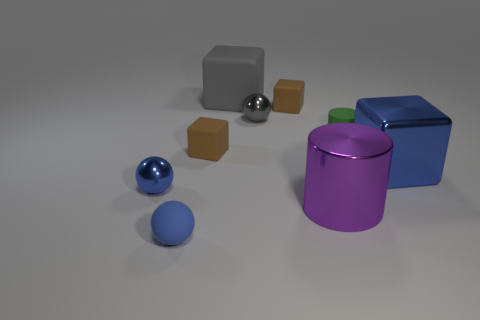What number of things are either small blocks to the left of the big gray matte cube or large cubes?
Ensure brevity in your answer.  3. The tiny shiny object to the right of the big block to the left of the big shiny thing right of the purple metallic cylinder is what shape?
Ensure brevity in your answer.  Sphere. What number of blue things have the same shape as the large purple object?
Offer a terse response. 0. There is a sphere that is the same color as the large rubber block; what material is it?
Ensure brevity in your answer.  Metal. Do the tiny cylinder and the big cylinder have the same material?
Keep it short and to the point. No. There is a brown thing left of the small sphere that is to the right of the small blue matte sphere; what number of tiny rubber objects are in front of it?
Ensure brevity in your answer.  1. Is there a small red ball made of the same material as the blue block?
Ensure brevity in your answer.  No. There is a cube that is the same color as the tiny matte ball; what is its size?
Your response must be concise. Large. Is the number of brown blocks less than the number of small green cylinders?
Offer a terse response. No. There is a block that is to the right of the purple metallic cylinder; does it have the same color as the big cylinder?
Your answer should be compact. No. 